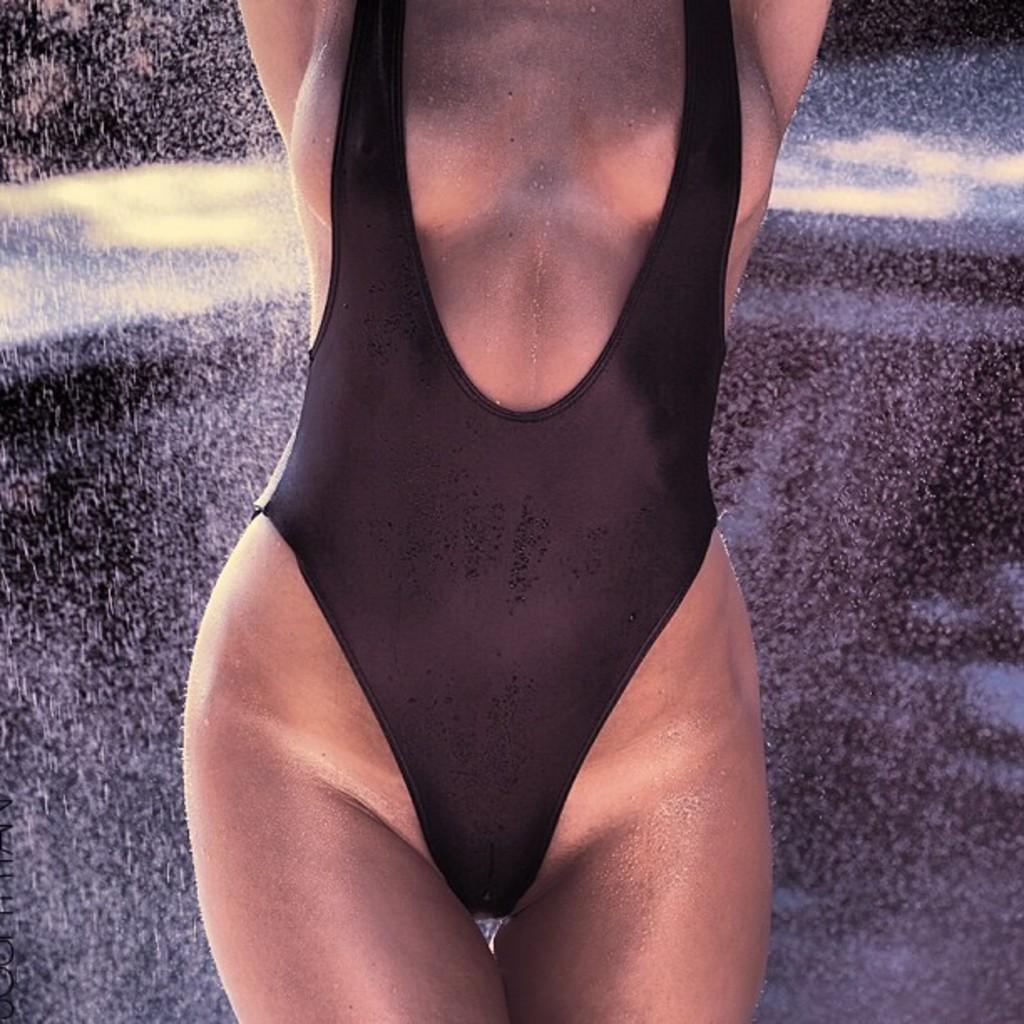Who is the main subject in the image? There is a woman in the image. What is the woman wearing? The woman is wearing a black dress. What can be seen behind the woman in the image? The woman is standing near a black wall. What type of pump can be seen in the image? There is no pump present in the image. Is there any spark visible in the image? There is no spark visible in the image. 